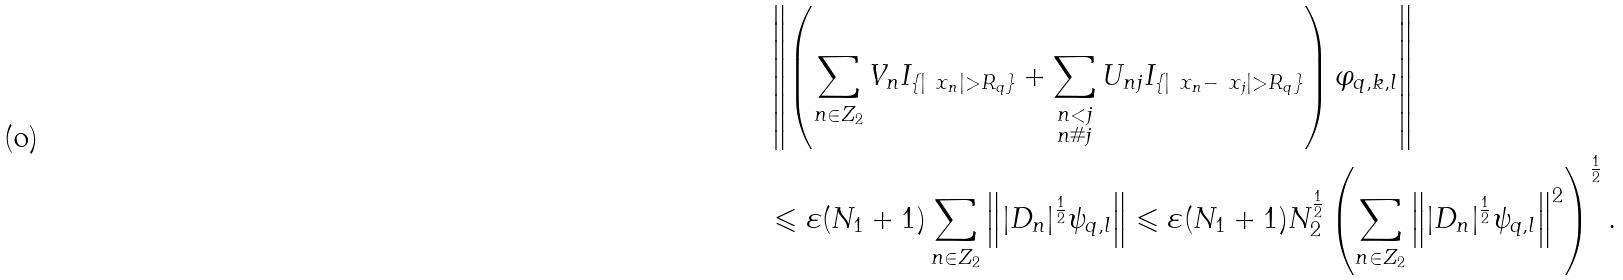<formula> <loc_0><loc_0><loc_500><loc_500>& \left \| \left ( \sum _ { n \in Z _ { 2 } } V _ { n } I _ { \{ | \ x _ { n } | > R _ { q } \} } + \sum _ { \substack { n < j \\ n \# j } } U _ { n j } I _ { \{ | \ x _ { n } - \ x _ { j } | > R _ { q } \} } \right ) \varphi _ { q , k , l } \right \| \\ & \leqslant \varepsilon ( N _ { 1 } + 1 ) \sum _ { n \in Z _ { 2 } } \left \| | D _ { n } | ^ { \frac { 1 } { 2 } } \psi _ { q , l } \right \| \leqslant \varepsilon ( N _ { 1 } + 1 ) N _ { 2 } ^ { \frac { 1 } { 2 } } \left ( \sum _ { n \in Z _ { 2 } } \left \| | D _ { n } | ^ { \frac { 1 } { 2 } } \psi _ { q , l } \right \| ^ { 2 } \right ) ^ { \frac { 1 } { 2 } } .</formula> 